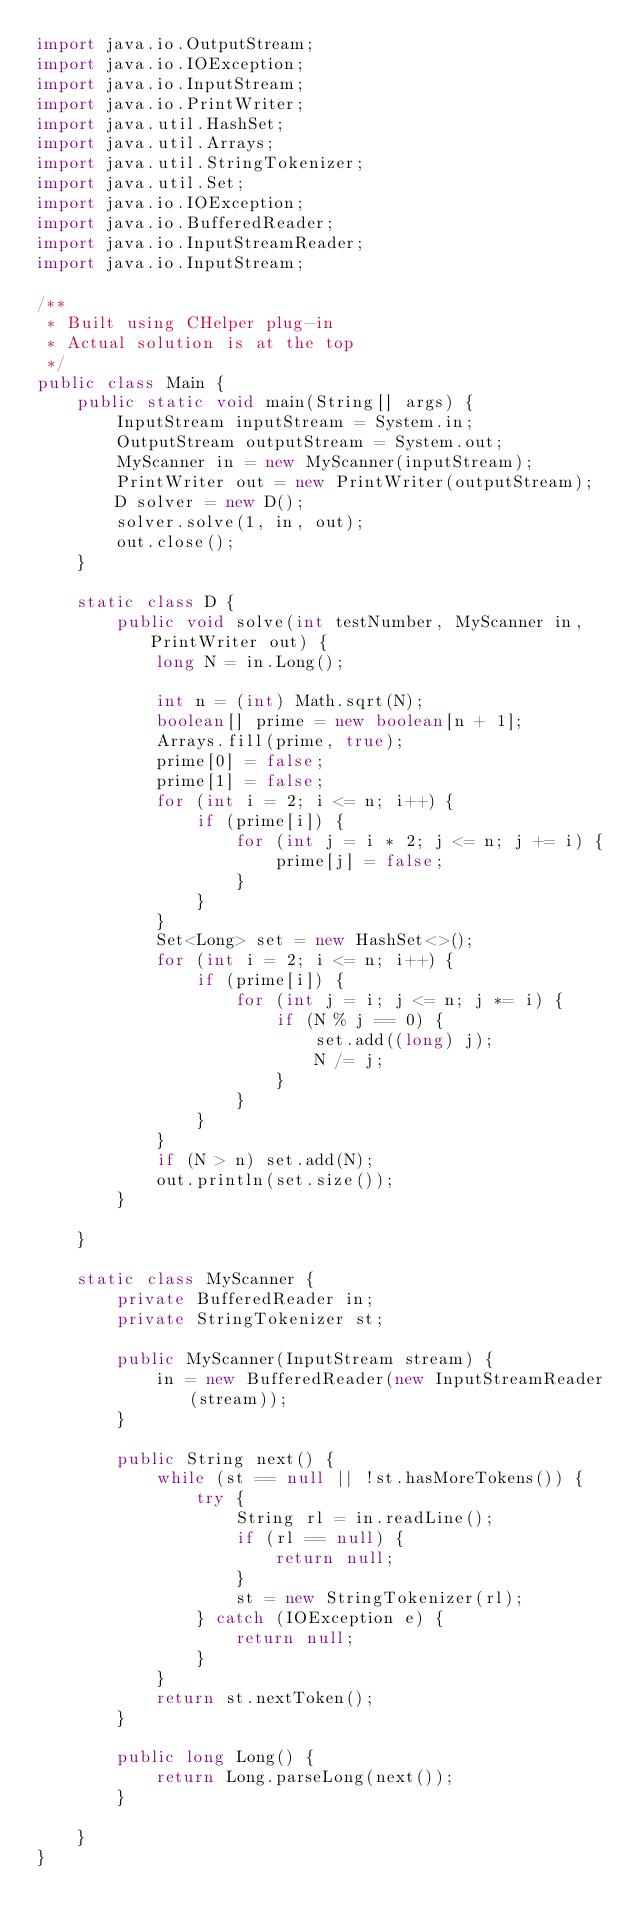Convert code to text. <code><loc_0><loc_0><loc_500><loc_500><_Java_>import java.io.OutputStream;
import java.io.IOException;
import java.io.InputStream;
import java.io.PrintWriter;
import java.util.HashSet;
import java.util.Arrays;
import java.util.StringTokenizer;
import java.util.Set;
import java.io.IOException;
import java.io.BufferedReader;
import java.io.InputStreamReader;
import java.io.InputStream;

/**
 * Built using CHelper plug-in
 * Actual solution is at the top
 */
public class Main {
    public static void main(String[] args) {
        InputStream inputStream = System.in;
        OutputStream outputStream = System.out;
        MyScanner in = new MyScanner(inputStream);
        PrintWriter out = new PrintWriter(outputStream);
        D solver = new D();
        solver.solve(1, in, out);
        out.close();
    }

    static class D {
        public void solve(int testNumber, MyScanner in, PrintWriter out) {
            long N = in.Long();

            int n = (int) Math.sqrt(N);
            boolean[] prime = new boolean[n + 1];
            Arrays.fill(prime, true);
            prime[0] = false;
            prime[1] = false;
            for (int i = 2; i <= n; i++) {
                if (prime[i]) {
                    for (int j = i * 2; j <= n; j += i) {
                        prime[j] = false;
                    }
                }
            }
            Set<Long> set = new HashSet<>();
            for (int i = 2; i <= n; i++) {
                if (prime[i]) {
                    for (int j = i; j <= n; j *= i) {
                        if (N % j == 0) {
                            set.add((long) j);
                            N /= j;
                        }
                    }
                }
            }
            if (N > n) set.add(N);
            out.println(set.size());
        }

    }

    static class MyScanner {
        private BufferedReader in;
        private StringTokenizer st;

        public MyScanner(InputStream stream) {
            in = new BufferedReader(new InputStreamReader(stream));
        }

        public String next() {
            while (st == null || !st.hasMoreTokens()) {
                try {
                    String rl = in.readLine();
                    if (rl == null) {
                        return null;
                    }
                    st = new StringTokenizer(rl);
                } catch (IOException e) {
                    return null;
                }
            }
            return st.nextToken();
        }

        public long Long() {
            return Long.parseLong(next());
        }

    }
}

</code> 